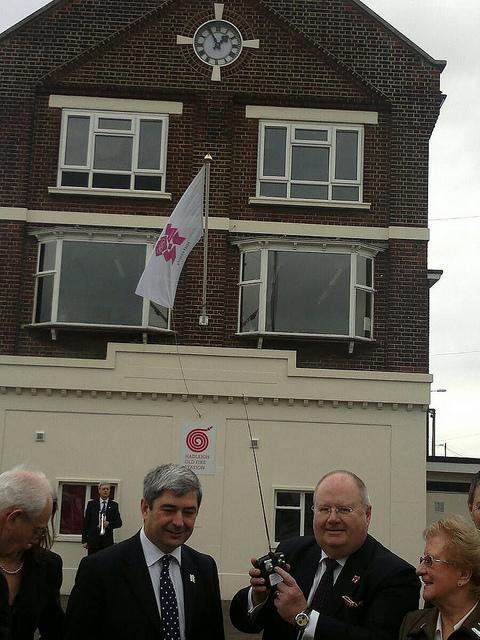How many people are in the photo?
Give a very brief answer. 5. How many windows are in this photo?
Give a very brief answer. 6. How many men are bald in this picture?
Give a very brief answer. 1. How many flags are there?
Give a very brief answer. 1. How many windows are visible?
Give a very brief answer. 4. How many people are there?
Give a very brief answer. 5. 